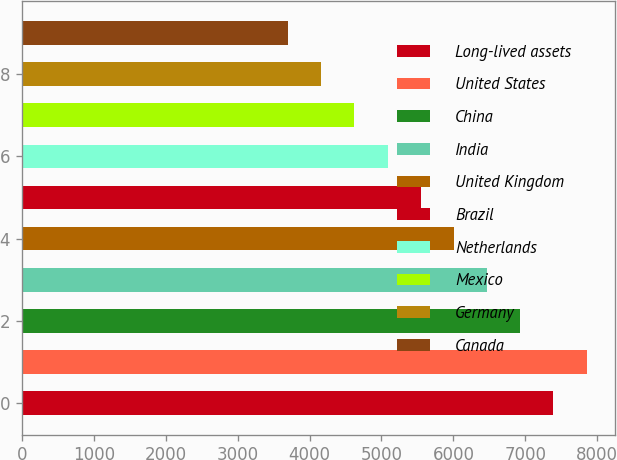Convert chart to OTSL. <chart><loc_0><loc_0><loc_500><loc_500><bar_chart><fcel>Long-lived assets<fcel>United States<fcel>China<fcel>India<fcel>United Kingdom<fcel>Brazil<fcel>Netherlands<fcel>Mexico<fcel>Germany<fcel>Canada<nl><fcel>7390.6<fcel>7851.7<fcel>6929.5<fcel>6468.4<fcel>6007.3<fcel>5546.2<fcel>5085.1<fcel>4624<fcel>4162.9<fcel>3701.8<nl></chart> 